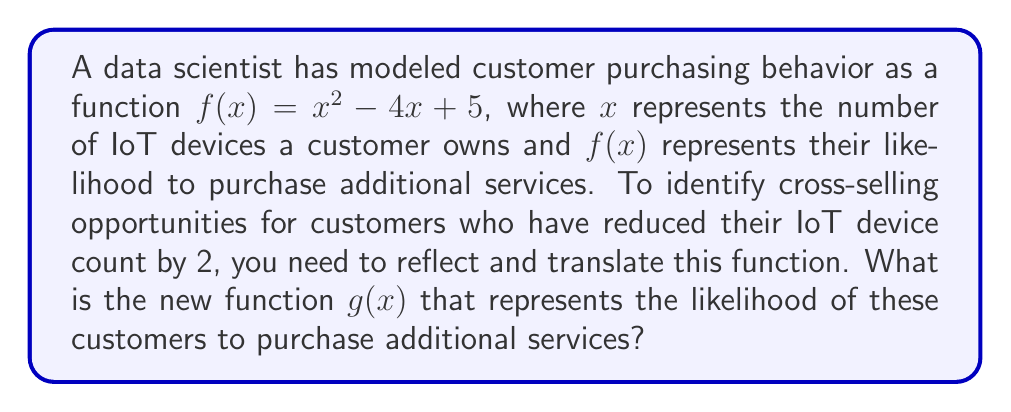Can you answer this question? 1. First, we need to reflect the function over the y-axis. This is done by replacing every $x$ with $-x$:
   $f(-x) = (-x)^2 - 4(-x) + 5$
   $f(-x) = x^2 + 4x + 5$

2. Next, we need to translate the function 2 units to the right to account for the reduction in IoT devices. This is done by replacing every $x$ with $(x-2)$:
   $g(x) = (x-2)^2 + 4(x-2) + 5$

3. Let's expand this equation:
   $g(x) = (x^2 - 4x + 4) + (4x - 8) + 5$
   $g(x) = x^2 - 4x + 4 + 4x - 8 + 5$

4. Simplify by combining like terms:
   $g(x) = x^2 + 1$

Therefore, the new function $g(x)$ that represents the likelihood of customers who have reduced their IoT device count by 2 to purchase additional services is $x^2 + 1$.
Answer: $g(x) = x^2 + 1$ 